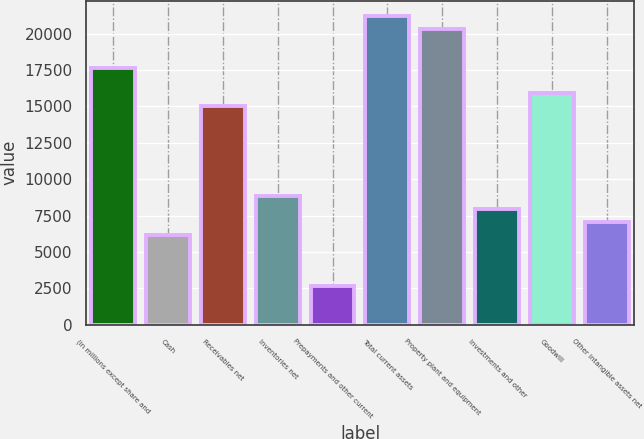Convert chart. <chart><loc_0><loc_0><loc_500><loc_500><bar_chart><fcel>(in millions except share and<fcel>Cash<fcel>Receivables net<fcel>Inventories net<fcel>Prepayments and other current<fcel>Total current assets<fcel>Property plant and equipment<fcel>Investments and other<fcel>Goodwill<fcel>Other intangible assets net<nl><fcel>17666.9<fcel>6185.04<fcel>15017.2<fcel>8834.7<fcel>2652.16<fcel>21199.8<fcel>20316.6<fcel>7951.48<fcel>15900.5<fcel>7068.26<nl></chart> 